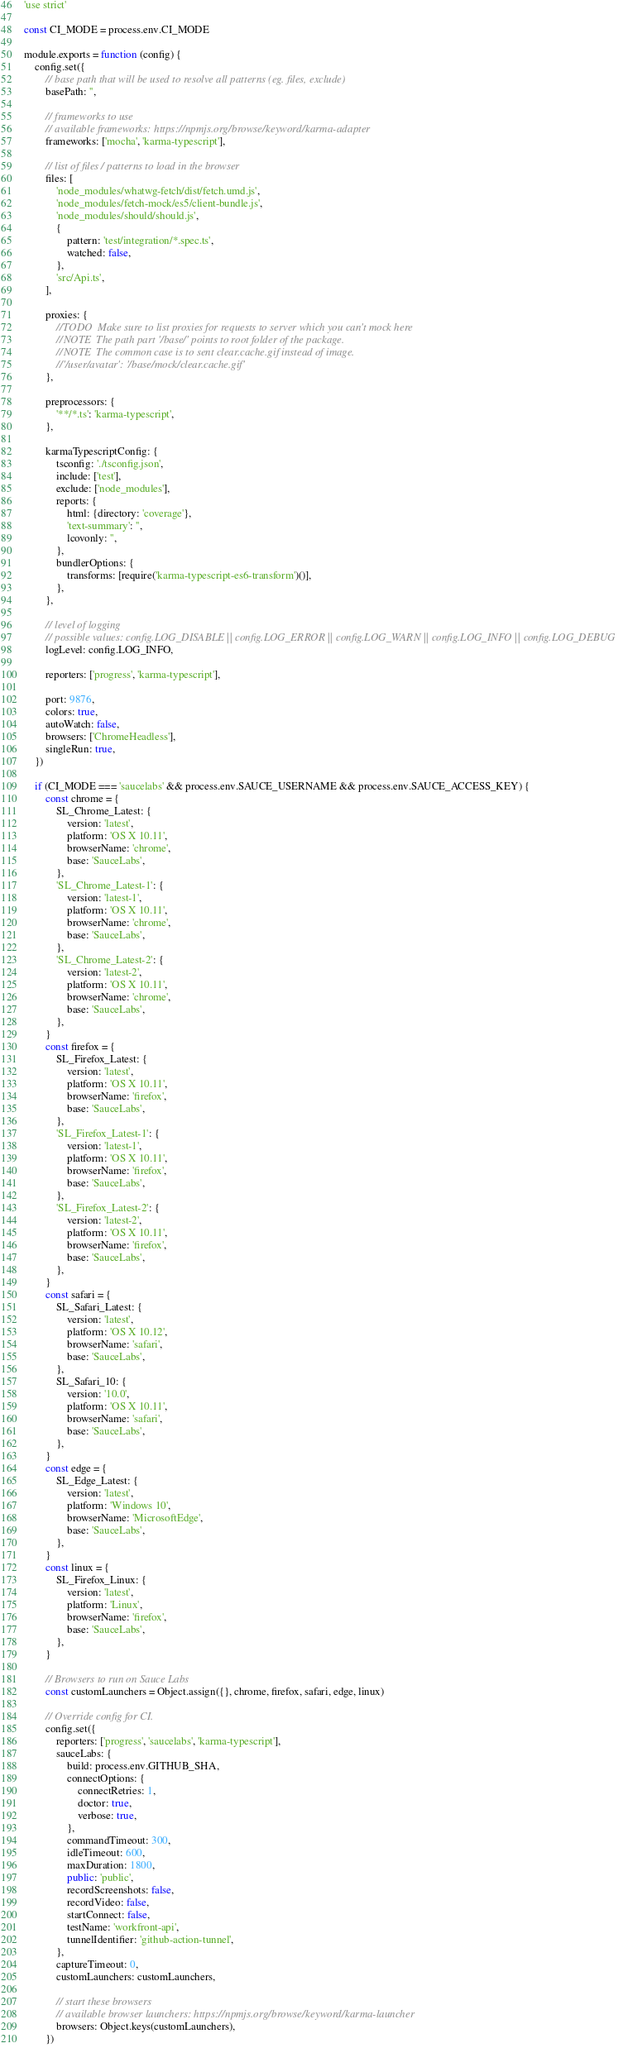Convert code to text. <code><loc_0><loc_0><loc_500><loc_500><_JavaScript_>'use strict'

const CI_MODE = process.env.CI_MODE

module.exports = function (config) {
    config.set({
        // base path that will be used to resolve all patterns (eg. files, exclude)
        basePath: '',

        // frameworks to use
        // available frameworks: https://npmjs.org/browse/keyword/karma-adapter
        frameworks: ['mocha', 'karma-typescript'],

        // list of files / patterns to load in the browser
        files: [
            'node_modules/whatwg-fetch/dist/fetch.umd.js',
            'node_modules/fetch-mock/es5/client-bundle.js',
            'node_modules/should/should.js',
            {
                pattern: 'test/integration/*.spec.ts',
                watched: false,
            },
            'src/Api.ts',
        ],

        proxies: {
            //TODO  Make sure to list proxies for requests to server which you can't mock here
            //NOTE  The path part '/base/' points to root folder of the package.
            //NOTE  The common case is to sent clear.cache.gif instead of image.
            //'/user/avatar': '/base/mock/clear.cache.gif'
        },

        preprocessors: {
            '**/*.ts': 'karma-typescript',
        },

        karmaTypescriptConfig: {
            tsconfig: './tsconfig.json',
            include: ['test'],
            exclude: ['node_modules'],
            reports: {
                html: {directory: 'coverage'},
                'text-summary': '',
                lcovonly: '',
            },
            bundlerOptions: {
                transforms: [require('karma-typescript-es6-transform')()],
            },
        },

        // level of logging
        // possible values: config.LOG_DISABLE || config.LOG_ERROR || config.LOG_WARN || config.LOG_INFO || config.LOG_DEBUG
        logLevel: config.LOG_INFO,

        reporters: ['progress', 'karma-typescript'],

        port: 9876,
        colors: true,
        autoWatch: false,
        browsers: ['ChromeHeadless'],
        singleRun: true,
    })

    if (CI_MODE === 'saucelabs' && process.env.SAUCE_USERNAME && process.env.SAUCE_ACCESS_KEY) {
        const chrome = {
            SL_Chrome_Latest: {
                version: 'latest',
                platform: 'OS X 10.11',
                browserName: 'chrome',
                base: 'SauceLabs',
            },
            'SL_Chrome_Latest-1': {
                version: 'latest-1',
                platform: 'OS X 10.11',
                browserName: 'chrome',
                base: 'SauceLabs',
            },
            'SL_Chrome_Latest-2': {
                version: 'latest-2',
                platform: 'OS X 10.11',
                browserName: 'chrome',
                base: 'SauceLabs',
            },
        }
        const firefox = {
            SL_Firefox_Latest: {
                version: 'latest',
                platform: 'OS X 10.11',
                browserName: 'firefox',
                base: 'SauceLabs',
            },
            'SL_Firefox_Latest-1': {
                version: 'latest-1',
                platform: 'OS X 10.11',
                browserName: 'firefox',
                base: 'SauceLabs',
            },
            'SL_Firefox_Latest-2': {
                version: 'latest-2',
                platform: 'OS X 10.11',
                browserName: 'firefox',
                base: 'SauceLabs',
            },
        }
        const safari = {
            SL_Safari_Latest: {
                version: 'latest',
                platform: 'OS X 10.12',
                browserName: 'safari',
                base: 'SauceLabs',
            },
            SL_Safari_10: {
                version: '10.0',
                platform: 'OS X 10.11',
                browserName: 'safari',
                base: 'SauceLabs',
            },
        }
        const edge = {
            SL_Edge_Latest: {
                version: 'latest',
                platform: 'Windows 10',
                browserName: 'MicrosoftEdge',
                base: 'SauceLabs',
            },
        }
        const linux = {
            SL_Firefox_Linux: {
                version: 'latest',
                platform: 'Linux',
                browserName: 'firefox',
                base: 'SauceLabs',
            },
        }

        // Browsers to run on Sauce Labs
        const customLaunchers = Object.assign({}, chrome, firefox, safari, edge, linux)

        // Override config for CI.
        config.set({
            reporters: ['progress', 'saucelabs', 'karma-typescript'],
            sauceLabs: {
                build: process.env.GITHUB_SHA,
                connectOptions: {
                    connectRetries: 1,
                    doctor: true,
                    verbose: true,
                },
                commandTimeout: 300,
                idleTimeout: 600,
                maxDuration: 1800,
                public: 'public',
                recordScreenshots: false,
                recordVideo: false,
                startConnect: false,
                testName: 'workfront-api',
                tunnelIdentifier: 'github-action-tunnel',
            },
            captureTimeout: 0,
            customLaunchers: customLaunchers,

            // start these browsers
            // available browser launchers: https://npmjs.org/browse/keyword/karma-launcher
            browsers: Object.keys(customLaunchers),
        })</code> 